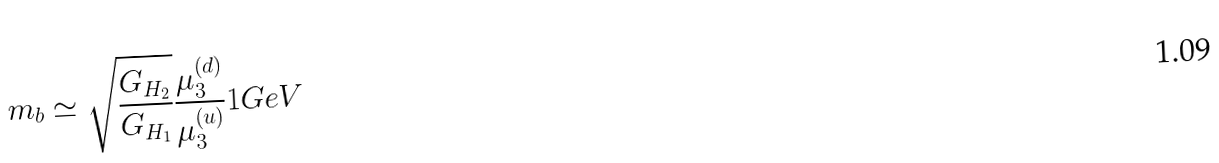<formula> <loc_0><loc_0><loc_500><loc_500>m _ { b } \simeq { \sqrt { \frac { G _ { H _ { 2 } } } { G _ { H _ { 1 } } } } } { \frac { \mu _ { 3 } ^ { ( d ) } } { \mu _ { 3 } ^ { ( u ) } } } { 1 } G e V</formula> 